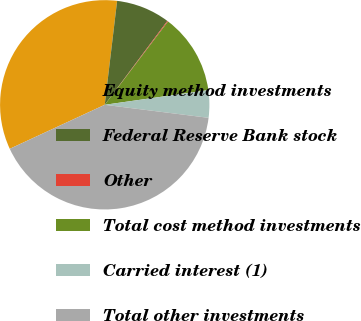Convert chart to OTSL. <chart><loc_0><loc_0><loc_500><loc_500><pie_chart><fcel>Equity method investments<fcel>Federal Reserve Bank stock<fcel>Other<fcel>Total cost method investments<fcel>Carried interest (1)<fcel>Total other investments<nl><fcel>33.8%<fcel>8.32%<fcel>0.13%<fcel>12.42%<fcel>4.23%<fcel>41.11%<nl></chart> 